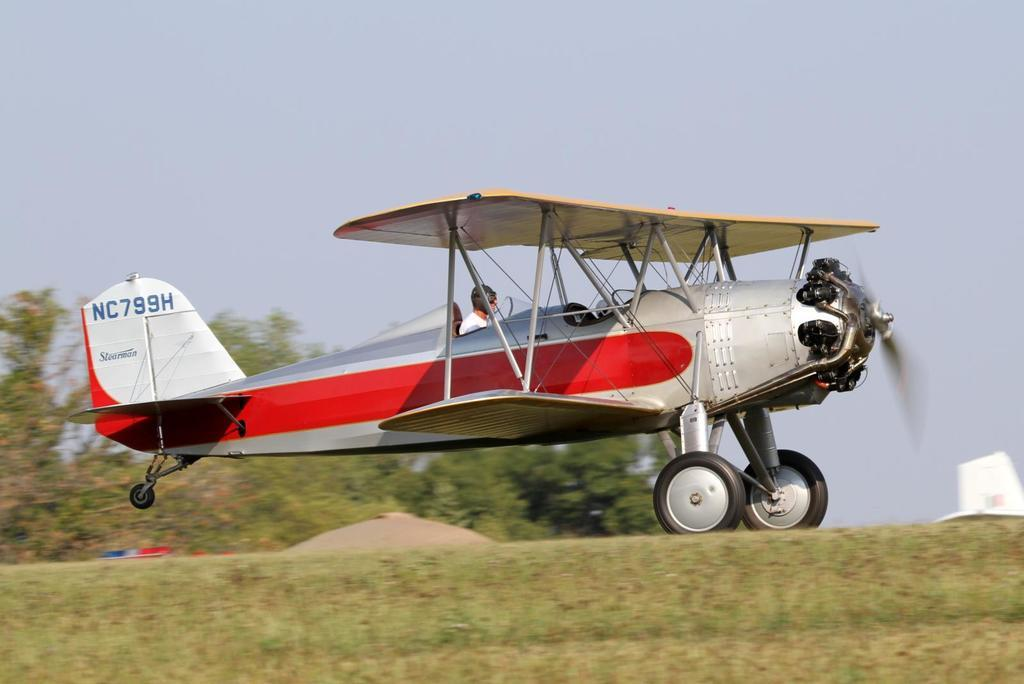<image>
Provide a brief description of the given image. The NC799H Stearman air craft preparing for takeoff. 